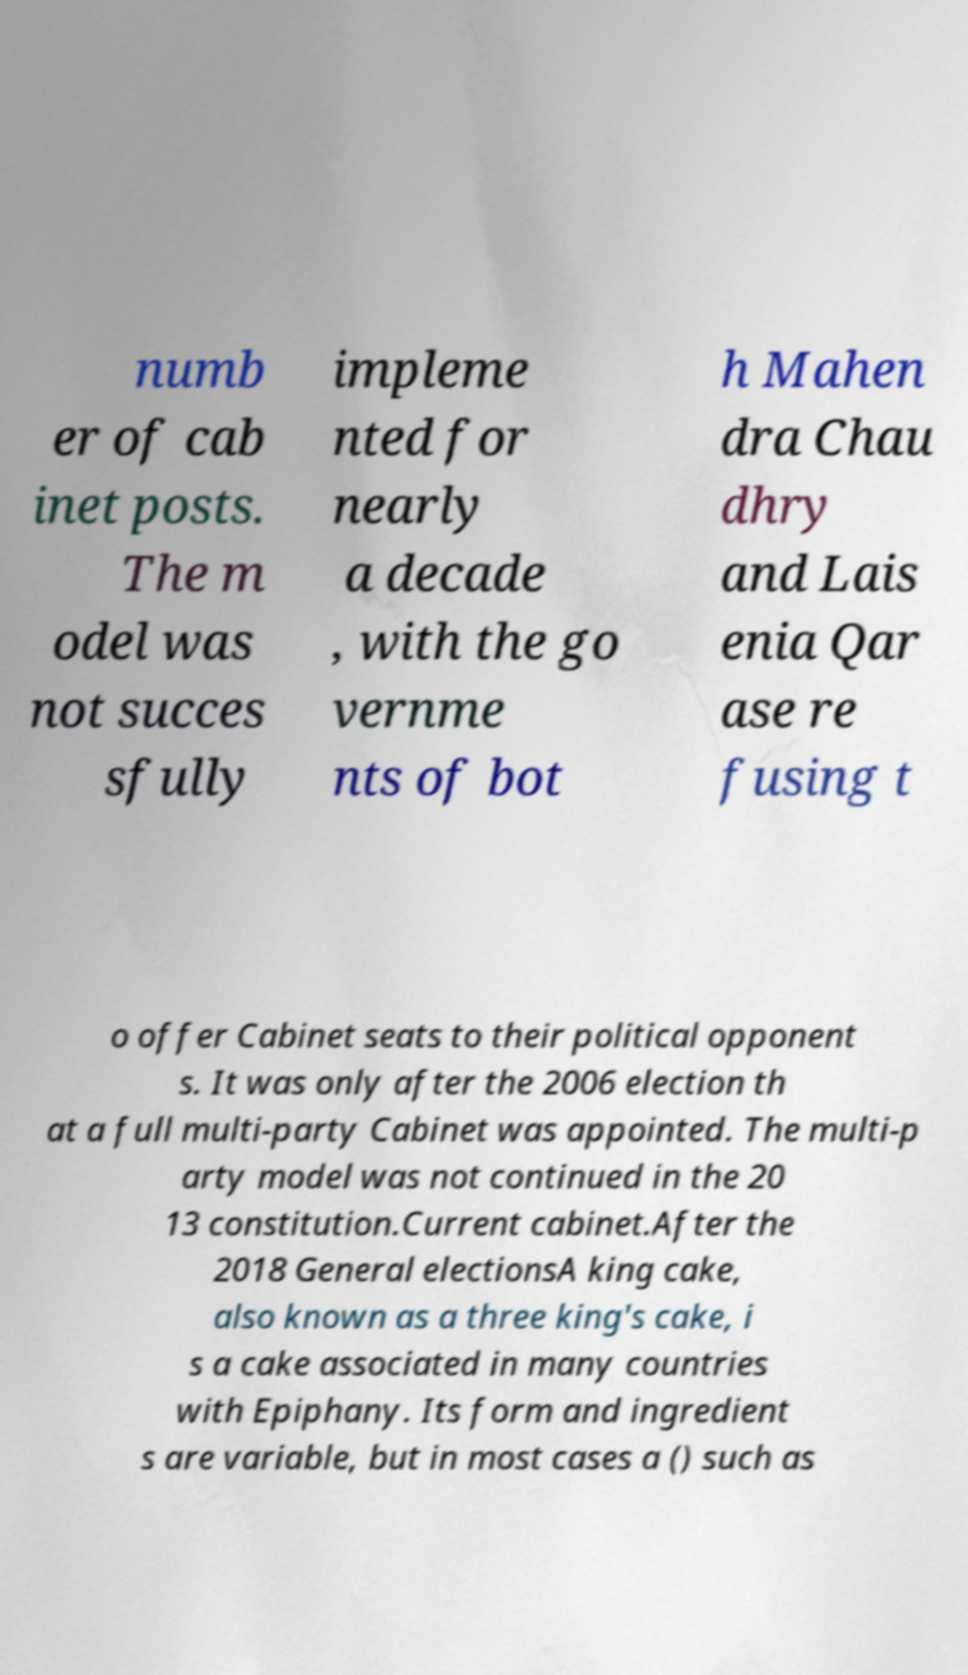There's text embedded in this image that I need extracted. Can you transcribe it verbatim? numb er of cab inet posts. The m odel was not succes sfully impleme nted for nearly a decade , with the go vernme nts of bot h Mahen dra Chau dhry and Lais enia Qar ase re fusing t o offer Cabinet seats to their political opponent s. It was only after the 2006 election th at a full multi-party Cabinet was appointed. The multi-p arty model was not continued in the 20 13 constitution.Current cabinet.After the 2018 General electionsA king cake, also known as a three king's cake, i s a cake associated in many countries with Epiphany. Its form and ingredient s are variable, but in most cases a () such as 